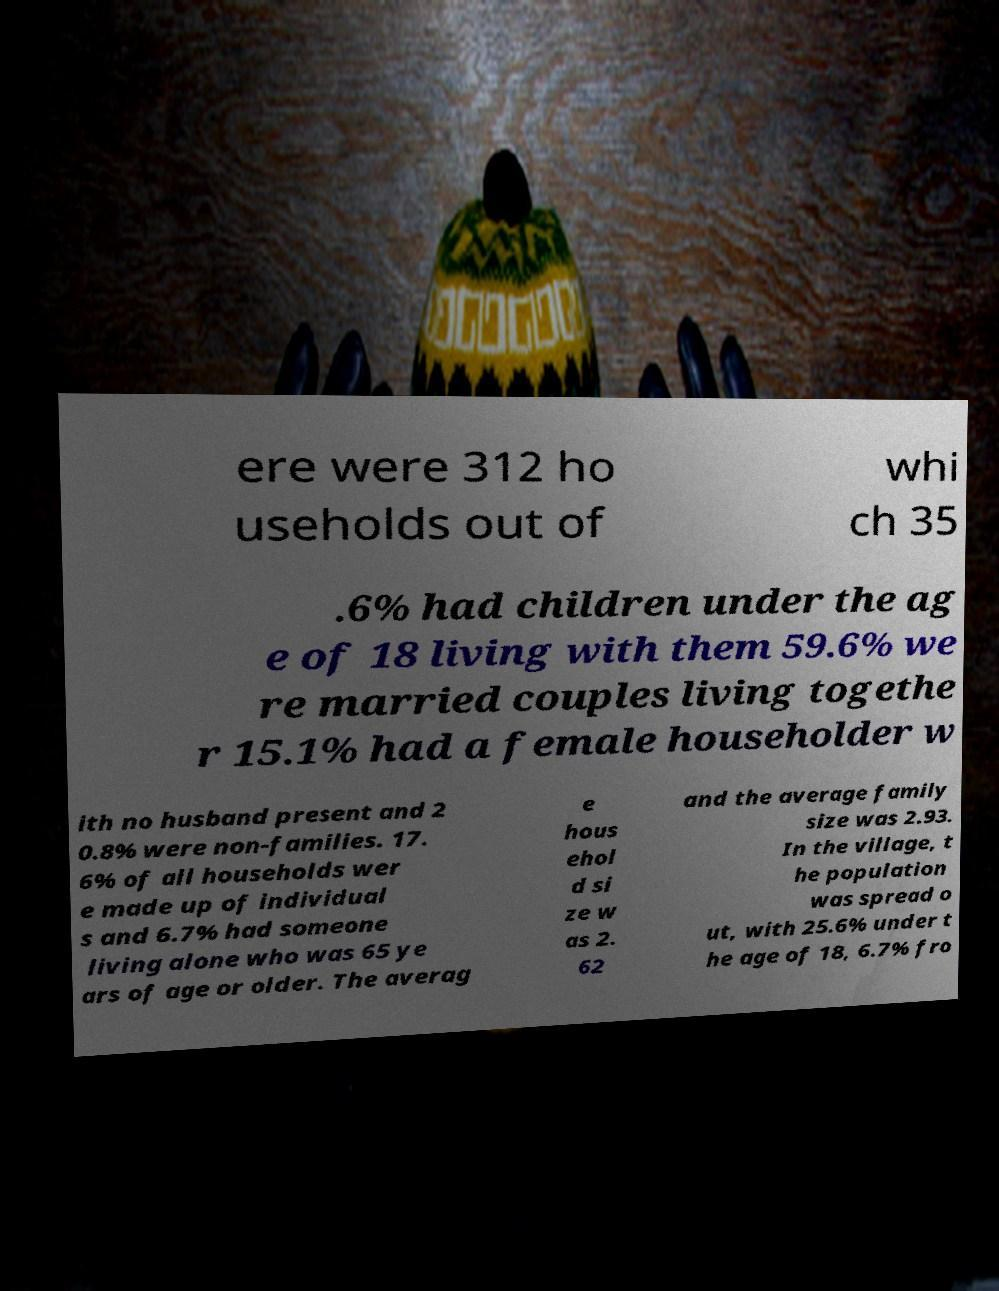Can you read and provide the text displayed in the image?This photo seems to have some interesting text. Can you extract and type it out for me? ere were 312 ho useholds out of whi ch 35 .6% had children under the ag e of 18 living with them 59.6% we re married couples living togethe r 15.1% had a female householder w ith no husband present and 2 0.8% were non-families. 17. 6% of all households wer e made up of individual s and 6.7% had someone living alone who was 65 ye ars of age or older. The averag e hous ehol d si ze w as 2. 62 and the average family size was 2.93. In the village, t he population was spread o ut, with 25.6% under t he age of 18, 6.7% fro 